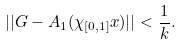<formula> <loc_0><loc_0><loc_500><loc_500>| | G - A _ { 1 } ( \chi _ { [ 0 , 1 ] } x ) | | < \frac { 1 } { k } .</formula> 